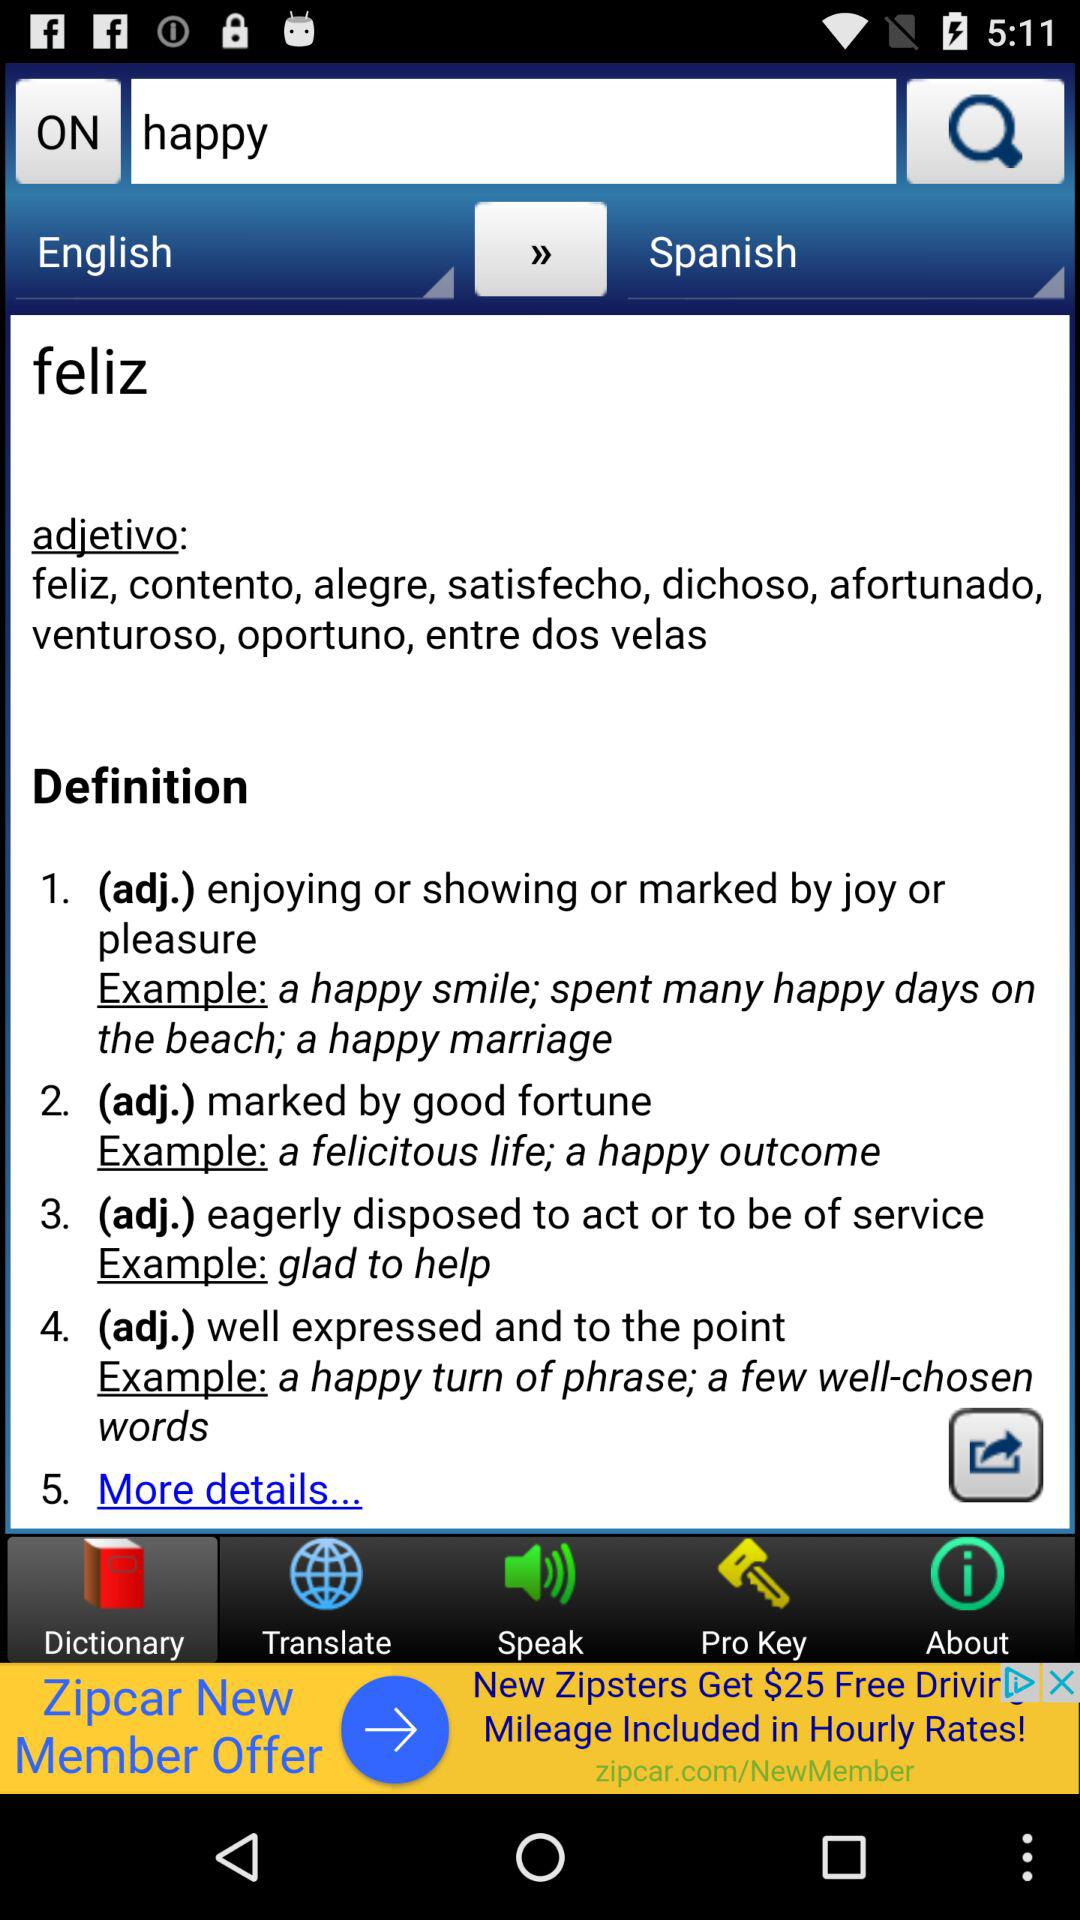Which tab is selected? The selected tab is "Dictionary". 